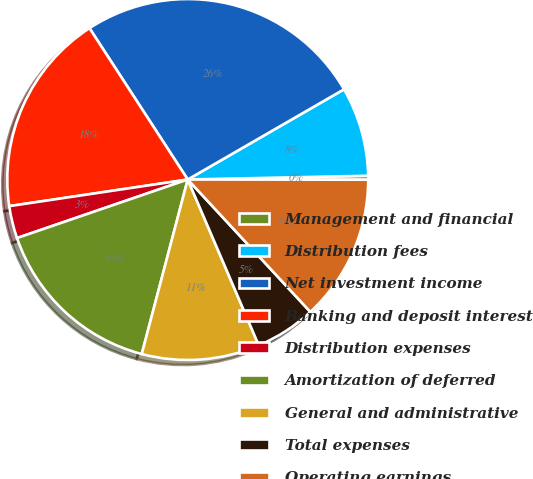Convert chart. <chart><loc_0><loc_0><loc_500><loc_500><pie_chart><fcel>Management and financial<fcel>Distribution fees<fcel>Net investment income<fcel>Banking and deposit interest<fcel>Distribution expenses<fcel>Amortization of deferred<fcel>General and administrative<fcel>Total expenses<fcel>Operating earnings<nl><fcel>0.35%<fcel>8.0%<fcel>25.83%<fcel>18.19%<fcel>2.9%<fcel>15.64%<fcel>10.54%<fcel>5.45%<fcel>13.09%<nl></chart> 